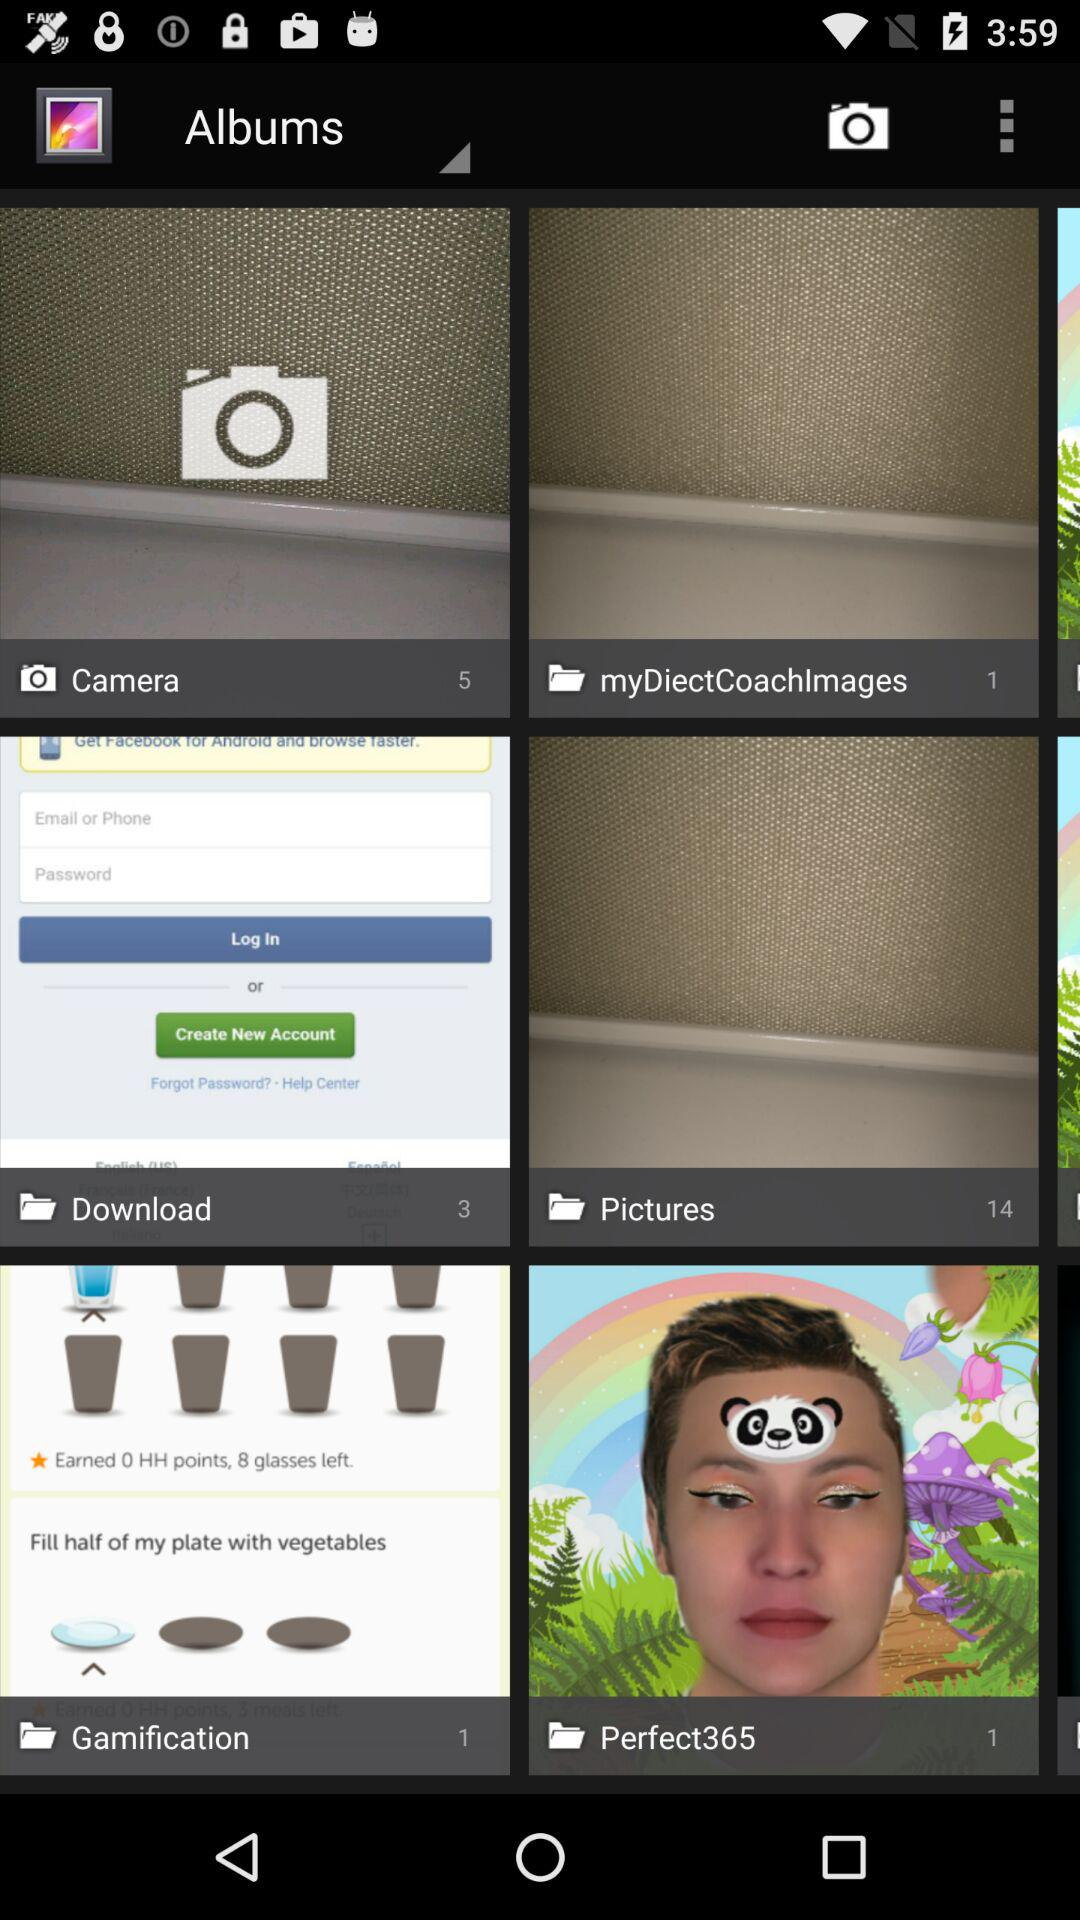How many items have the text 'Camera' in their title?
Answer the question using a single word or phrase. 1 